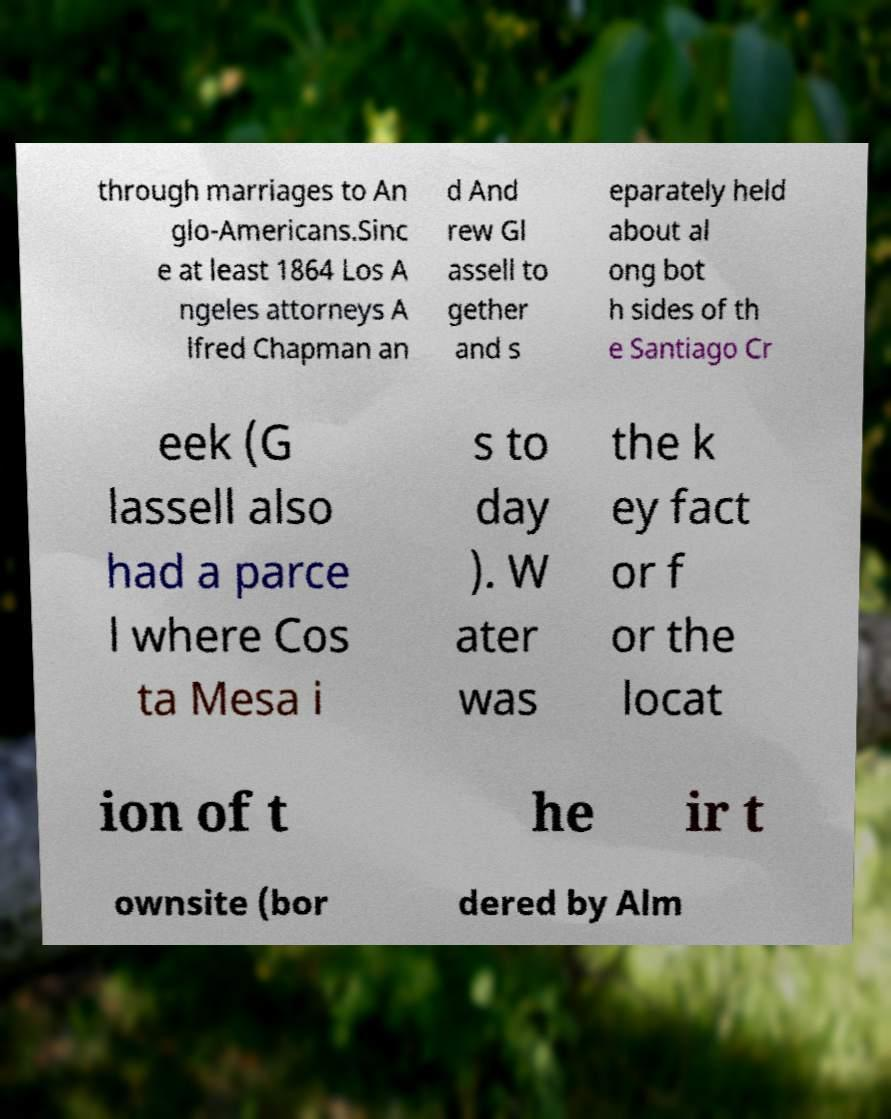Please read and relay the text visible in this image. What does it say? through marriages to An glo-Americans.Sinc e at least 1864 Los A ngeles attorneys A lfred Chapman an d And rew Gl assell to gether and s eparately held about al ong bot h sides of th e Santiago Cr eek (G lassell also had a parce l where Cos ta Mesa i s to day ). W ater was the k ey fact or f or the locat ion of t he ir t ownsite (bor dered by Alm 